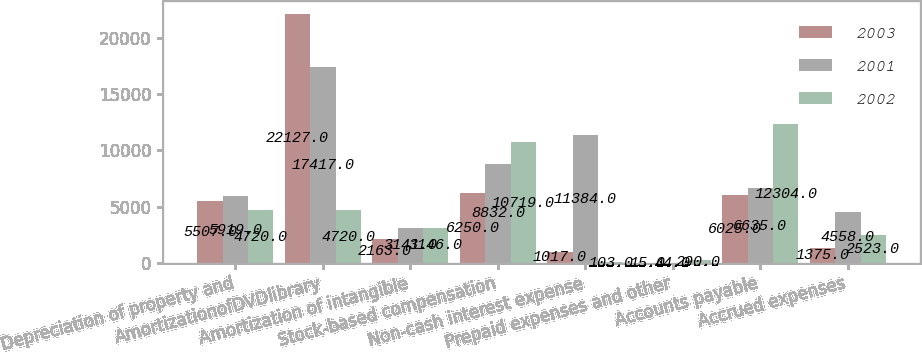Convert chart. <chart><loc_0><loc_0><loc_500><loc_500><stacked_bar_chart><ecel><fcel>Depreciation of property and<fcel>AmortizationofDVDlibrary<fcel>Amortization of intangible<fcel>Stock-based compensation<fcel>Non-cash interest expense<fcel>Prepaid expenses and other<fcel>Accounts payable<fcel>Accrued expenses<nl><fcel>2003<fcel>5507<fcel>22127<fcel>2163<fcel>6250<fcel>1017<fcel>15<fcel>6025<fcel>1375<nl><fcel>2001<fcel>5919<fcel>17417<fcel>3141<fcel>8832<fcel>11384<fcel>44<fcel>6635<fcel>4558<nl><fcel>2002<fcel>4720<fcel>4720<fcel>3146<fcel>10719<fcel>103<fcel>290<fcel>12304<fcel>2523<nl></chart> 